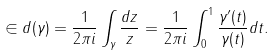<formula> <loc_0><loc_0><loc_500><loc_500>\in d ( \gamma ) = \frac { 1 } { 2 \pi i } \int _ { \gamma } \frac { d z } { z } = \frac { 1 } { 2 \pi i } \int _ { 0 } ^ { 1 } \frac { \gamma ^ { \prime } ( t ) } { \gamma ( t ) } d t .</formula> 